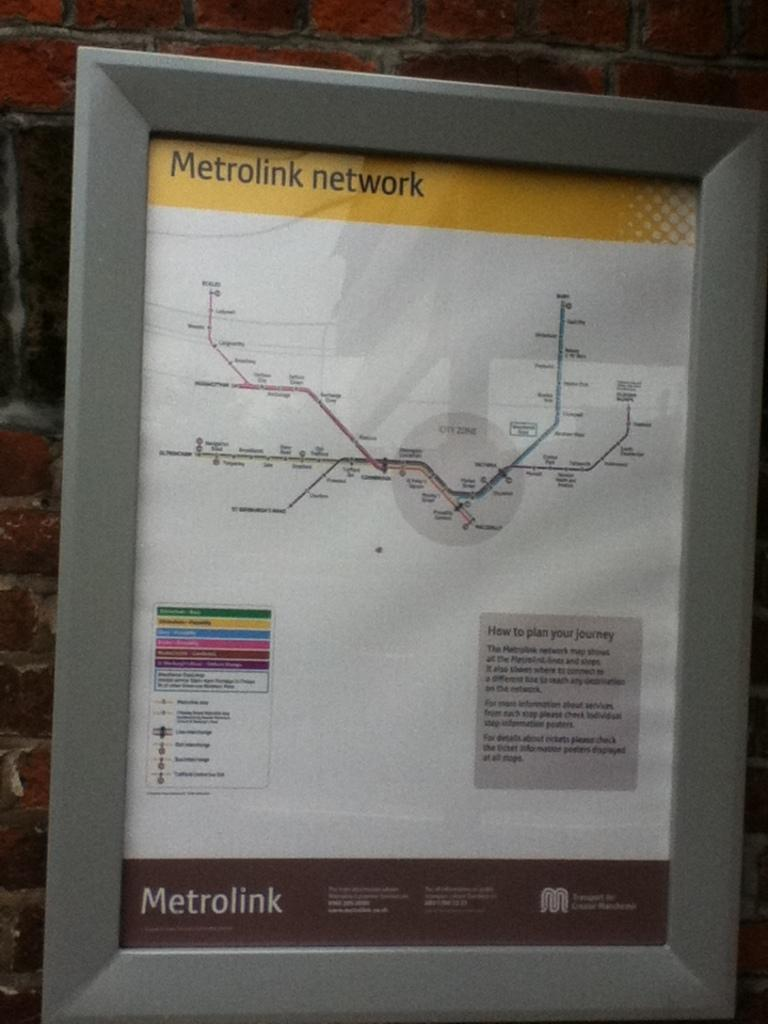<image>
Relay a brief, clear account of the picture shown. A Metrolink network map is in a grey colored frame. 